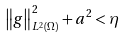Convert formula to latex. <formula><loc_0><loc_0><loc_500><loc_500>\left \| g \right \| _ { L ^ { 2 } ( \Omega ) } ^ { 2 } + a ^ { 2 } < \eta</formula> 